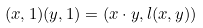Convert formula to latex. <formula><loc_0><loc_0><loc_500><loc_500>( x , 1 ) ( y , 1 ) = ( x \cdot y , l ( x , y ) )</formula> 